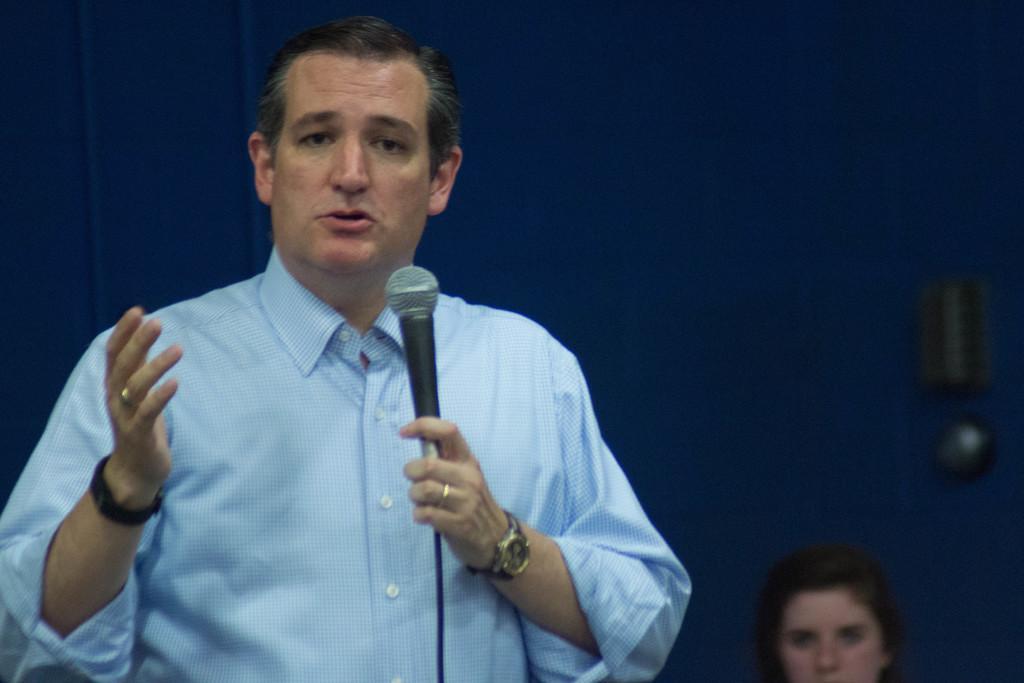How would you summarize this image in a sentence or two? In this picture we can see a man is talking with help of microphone in the background woman is seated. 